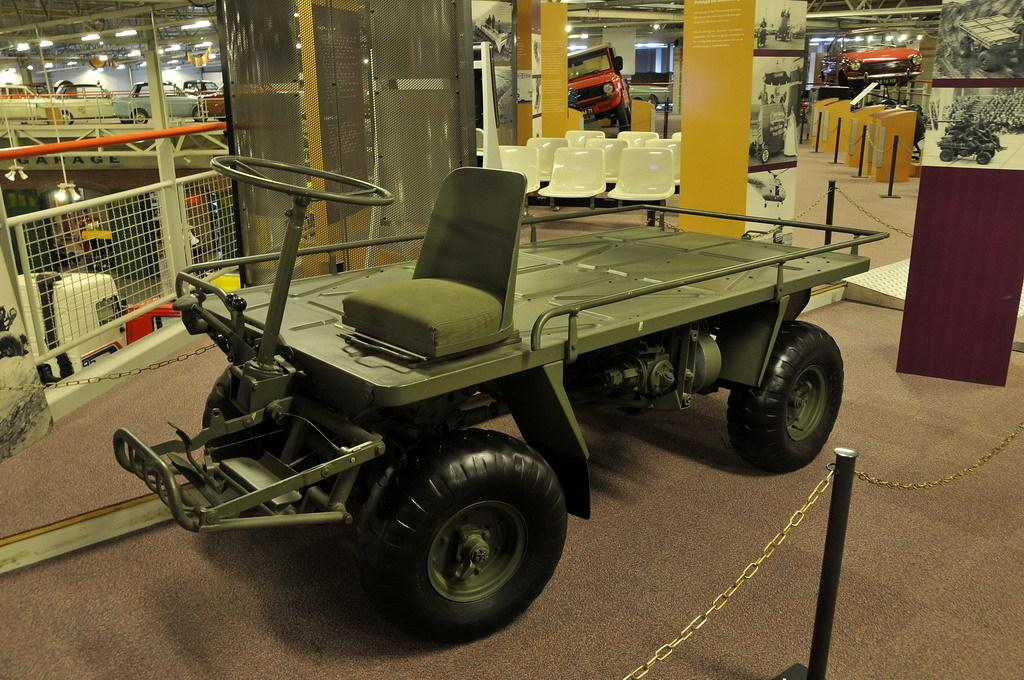What is the main subject of the image? There is a vehicle in the image. What can be seen in the background of the image? There are pillars in the background of the image. What might be the location or setting of the image? The image appears to depict a vehicle parking area. How many pies are visible on the pot in the image? There is no pot or pies present in the image. What type of kettle is being used to cook the vehicle in the image? There is no kettle or cooking involved in the image; it depicts a vehicle in a parking area. 